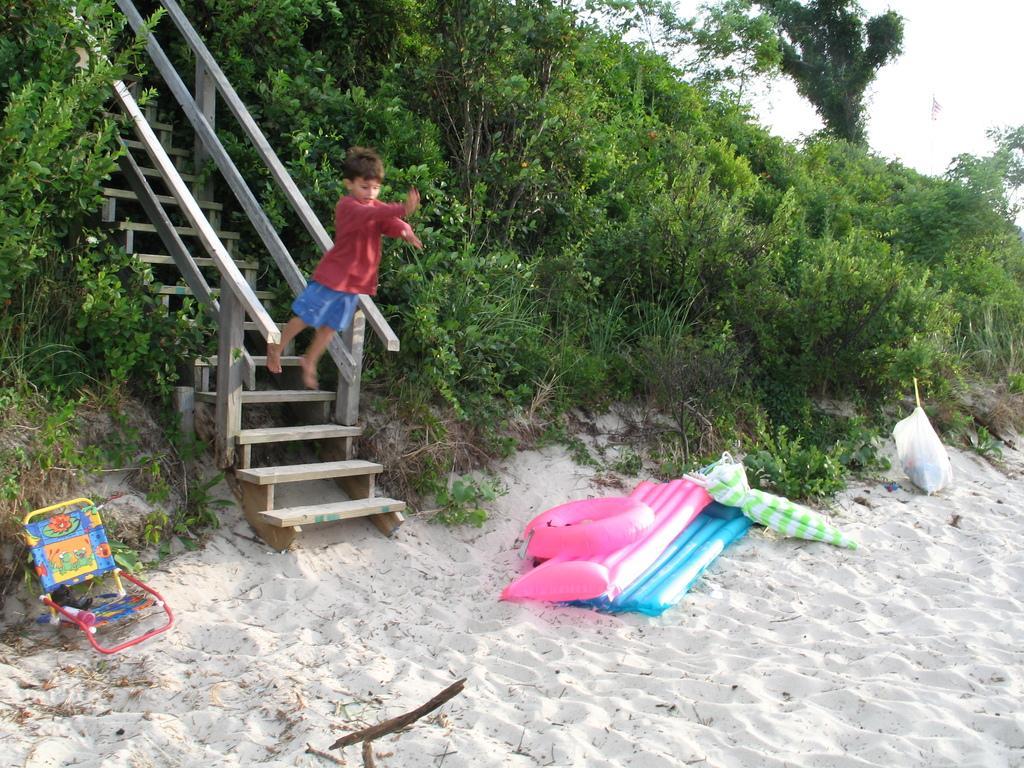In one or two sentences, can you explain what this image depicts? In this image there is an umbrella, cover, inflatable chairs, inflatable ring , chair, on the sand, staircase, plants, grass, trees, a boy jumping from the staircase, sky. 